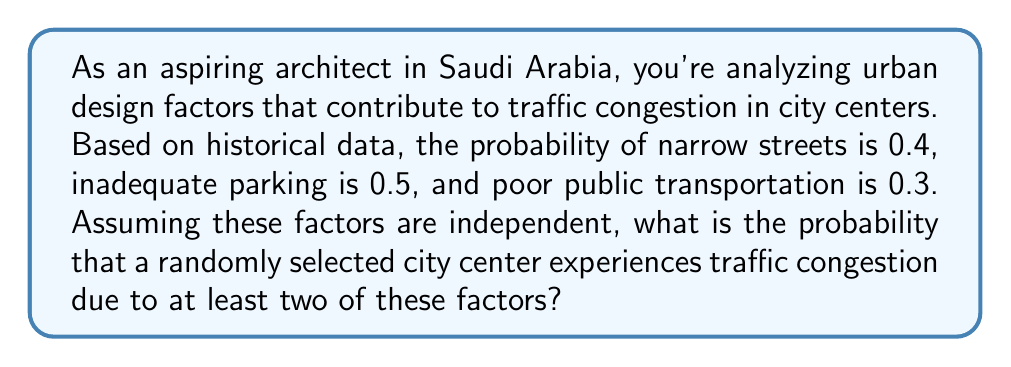Help me with this question. Let's approach this step-by-step using probability theory:

1) Define events:
   A: narrow streets
   B: inadequate parking
   C: poor public transportation

2) Given probabilities:
   P(A) = 0.4
   P(B) = 0.5
   P(C) = 0.3

3) We need to find the probability of at least two factors occurring. This is equivalent to 1 minus the probability of zero or one factor occurring.

4) Probability of zero factors:
   P(no factors) = (1-0.4)(1-0.5)(1-0.3) = 0.6 * 0.5 * 0.7 = 0.21

5) Probability of exactly one factor:
   P(only A) = 0.4 * 0.5 * 0.7 = 0.14
   P(only B) = 0.6 * 0.5 * 0.7 = 0.21
   P(only C) = 0.6 * 0.5 * 0.3 = 0.09
   P(one factor) = 0.14 + 0.21 + 0.09 = 0.44

6) Probability of at least two factors:
   P(at least two) = 1 - P(zero factors) - P(one factor)
                   = 1 - 0.21 - 0.44
                   = 0.35

Therefore, the probability of traffic congestion due to at least two factors is 0.35 or 35%.
Answer: 0.35 